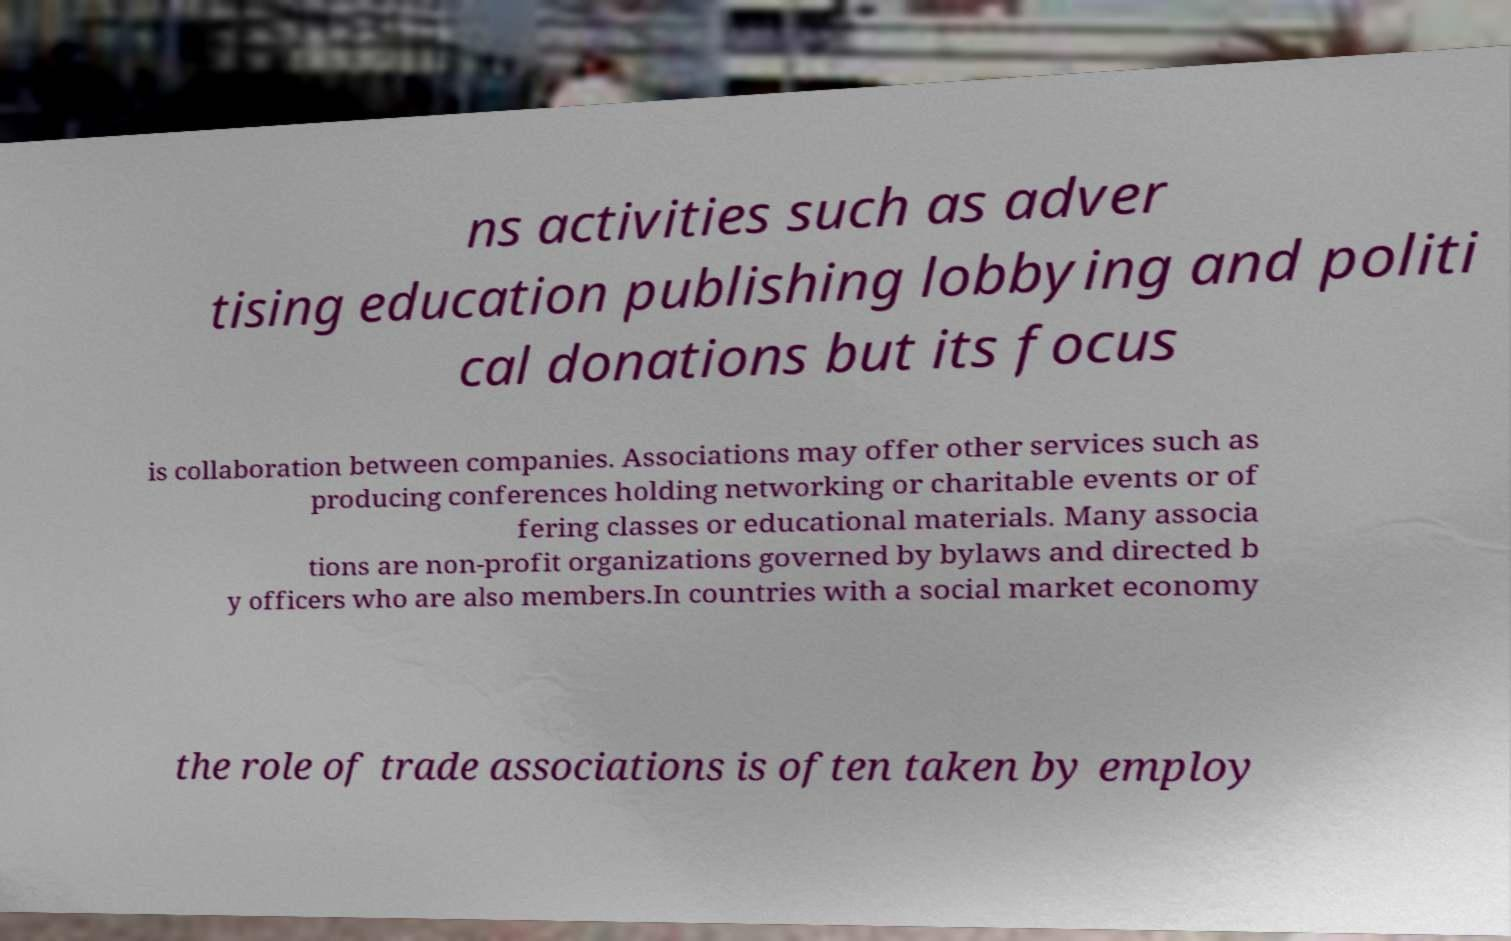I need the written content from this picture converted into text. Can you do that? ns activities such as adver tising education publishing lobbying and politi cal donations but its focus is collaboration between companies. Associations may offer other services such as producing conferences holding networking or charitable events or of fering classes or educational materials. Many associa tions are non-profit organizations governed by bylaws and directed b y officers who are also members.In countries with a social market economy the role of trade associations is often taken by employ 